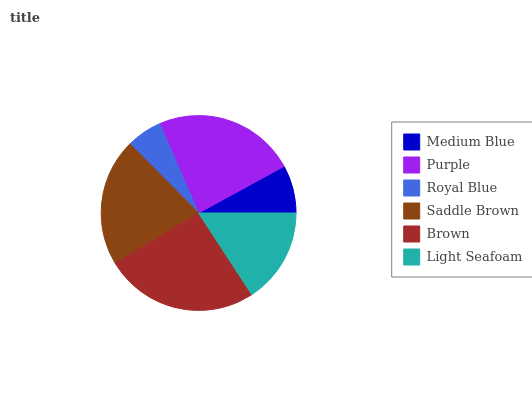Is Royal Blue the minimum?
Answer yes or no. Yes. Is Brown the maximum?
Answer yes or no. Yes. Is Purple the minimum?
Answer yes or no. No. Is Purple the maximum?
Answer yes or no. No. Is Purple greater than Medium Blue?
Answer yes or no. Yes. Is Medium Blue less than Purple?
Answer yes or no. Yes. Is Medium Blue greater than Purple?
Answer yes or no. No. Is Purple less than Medium Blue?
Answer yes or no. No. Is Saddle Brown the high median?
Answer yes or no. Yes. Is Light Seafoam the low median?
Answer yes or no. Yes. Is Light Seafoam the high median?
Answer yes or no. No. Is Medium Blue the low median?
Answer yes or no. No. 